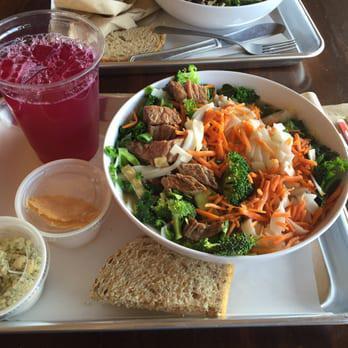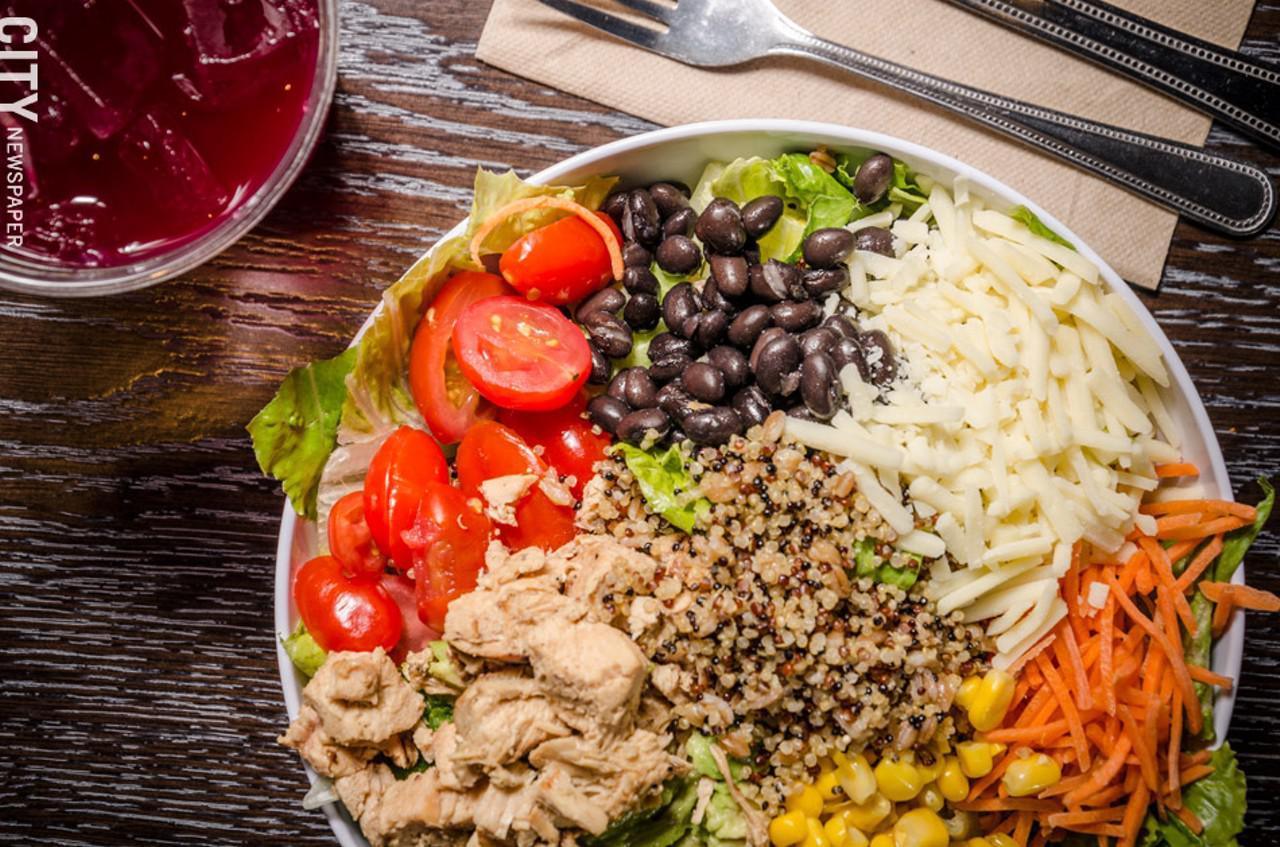The first image is the image on the left, the second image is the image on the right. For the images displayed, is the sentence "The left image shows two rows of seats with an aisle of wood-grain floor between them and angled architectural elements above them on the ceiling." factually correct? Answer yes or no. No. 